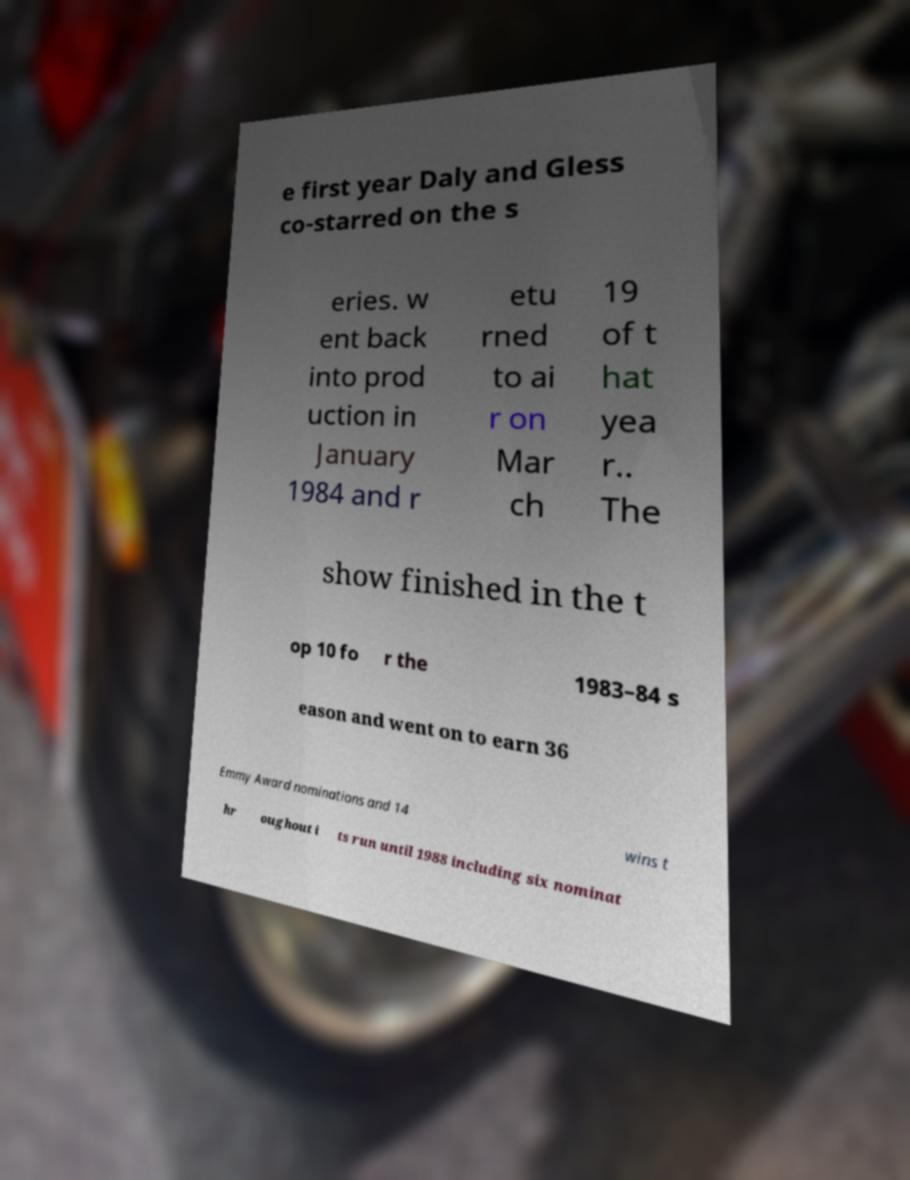I need the written content from this picture converted into text. Can you do that? e first year Daly and Gless co-starred on the s eries. w ent back into prod uction in January 1984 and r etu rned to ai r on Mar ch 19 of t hat yea r.. The show finished in the t op 10 fo r the 1983–84 s eason and went on to earn 36 Emmy Award nominations and 14 wins t hr oughout i ts run until 1988 including six nominat 